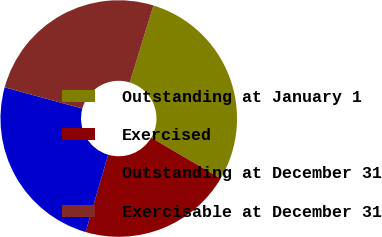Convert chart to OTSL. <chart><loc_0><loc_0><loc_500><loc_500><pie_chart><fcel>Outstanding at January 1<fcel>Exercised<fcel>Outstanding at December 31<fcel>Exercisable at December 31<nl><fcel>28.73%<fcel>21.05%<fcel>24.73%<fcel>25.49%<nl></chart> 